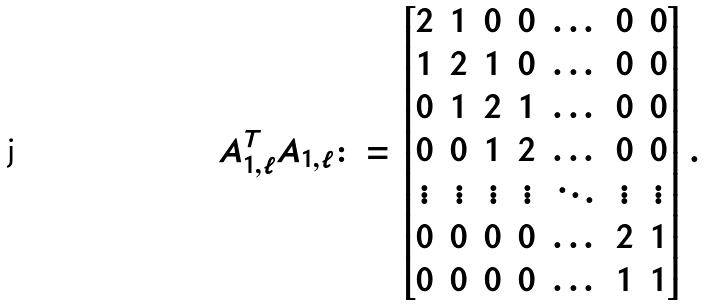<formula> <loc_0><loc_0><loc_500><loc_500>A _ { 1 , \ell } ^ { T } A _ { 1 , \ell } \colon = \begin{bmatrix} 2 & 1 & 0 & 0 & \dots & 0 & 0 \\ 1 & 2 & 1 & 0 & \dots & 0 & 0 \\ 0 & 1 & 2 & 1 & \dots & 0 & 0 \\ 0 & 0 & 1 & 2 & \dots & 0 & 0 \\ \vdots & \vdots & \vdots & \vdots & \ddots & \vdots & \vdots \\ 0 & 0 & 0 & 0 & \dots & 2 & 1 \\ 0 & 0 & 0 & 0 & \dots & 1 & 1 \end{bmatrix} .</formula> 